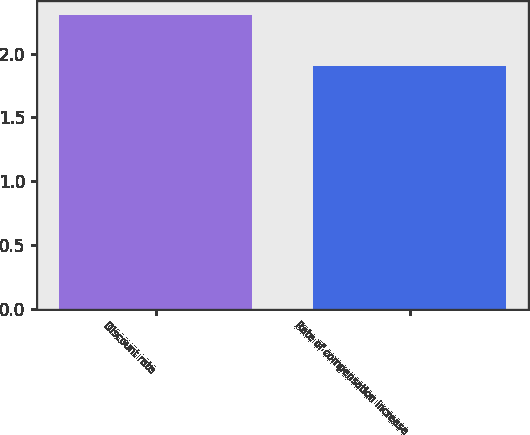Convert chart. <chart><loc_0><loc_0><loc_500><loc_500><bar_chart><fcel>Discount rate<fcel>Rate of compensation increase<nl><fcel>2.3<fcel>1.9<nl></chart> 